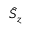Convert formula to latex. <formula><loc_0><loc_0><loc_500><loc_500>\hat { S } _ { z }</formula> 